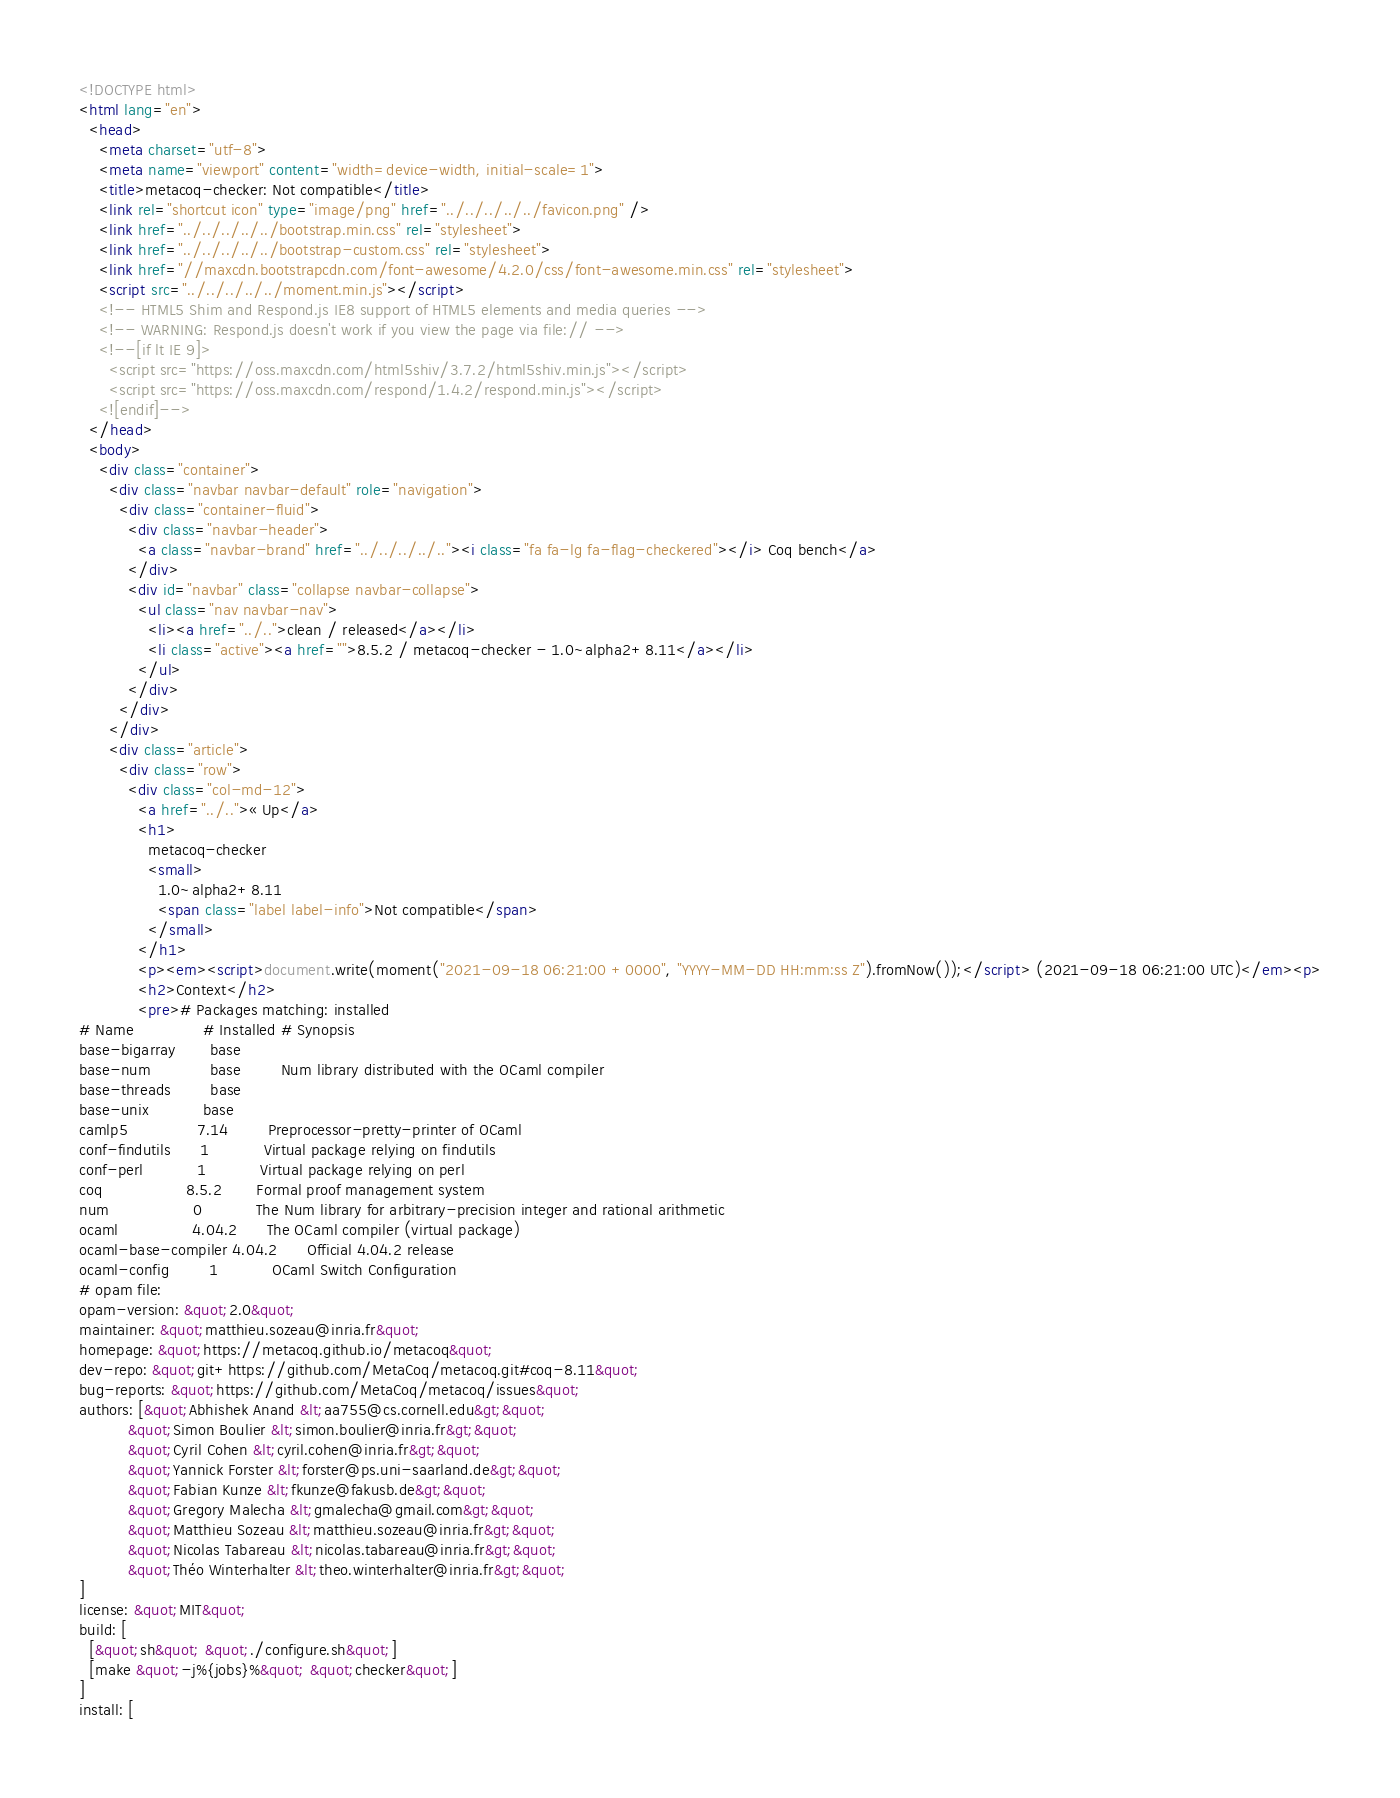<code> <loc_0><loc_0><loc_500><loc_500><_HTML_><!DOCTYPE html>
<html lang="en">
  <head>
    <meta charset="utf-8">
    <meta name="viewport" content="width=device-width, initial-scale=1">
    <title>metacoq-checker: Not compatible</title>
    <link rel="shortcut icon" type="image/png" href="../../../../../favicon.png" />
    <link href="../../../../../bootstrap.min.css" rel="stylesheet">
    <link href="../../../../../bootstrap-custom.css" rel="stylesheet">
    <link href="//maxcdn.bootstrapcdn.com/font-awesome/4.2.0/css/font-awesome.min.css" rel="stylesheet">
    <script src="../../../../../moment.min.js"></script>
    <!-- HTML5 Shim and Respond.js IE8 support of HTML5 elements and media queries -->
    <!-- WARNING: Respond.js doesn't work if you view the page via file:// -->
    <!--[if lt IE 9]>
      <script src="https://oss.maxcdn.com/html5shiv/3.7.2/html5shiv.min.js"></script>
      <script src="https://oss.maxcdn.com/respond/1.4.2/respond.min.js"></script>
    <![endif]-->
  </head>
  <body>
    <div class="container">
      <div class="navbar navbar-default" role="navigation">
        <div class="container-fluid">
          <div class="navbar-header">
            <a class="navbar-brand" href="../../../../.."><i class="fa fa-lg fa-flag-checkered"></i> Coq bench</a>
          </div>
          <div id="navbar" class="collapse navbar-collapse">
            <ul class="nav navbar-nav">
              <li><a href="../..">clean / released</a></li>
              <li class="active"><a href="">8.5.2 / metacoq-checker - 1.0~alpha2+8.11</a></li>
            </ul>
          </div>
        </div>
      </div>
      <div class="article">
        <div class="row">
          <div class="col-md-12">
            <a href="../..">« Up</a>
            <h1>
              metacoq-checker
              <small>
                1.0~alpha2+8.11
                <span class="label label-info">Not compatible</span>
              </small>
            </h1>
            <p><em><script>document.write(moment("2021-09-18 06:21:00 +0000", "YYYY-MM-DD HH:mm:ss Z").fromNow());</script> (2021-09-18 06:21:00 UTC)</em><p>
            <h2>Context</h2>
            <pre># Packages matching: installed
# Name              # Installed # Synopsis
base-bigarray       base
base-num            base        Num library distributed with the OCaml compiler
base-threads        base
base-unix           base
camlp5              7.14        Preprocessor-pretty-printer of OCaml
conf-findutils      1           Virtual package relying on findutils
conf-perl           1           Virtual package relying on perl
coq                 8.5.2       Formal proof management system
num                 0           The Num library for arbitrary-precision integer and rational arithmetic
ocaml               4.04.2      The OCaml compiler (virtual package)
ocaml-base-compiler 4.04.2      Official 4.04.2 release
ocaml-config        1           OCaml Switch Configuration
# opam file:
opam-version: &quot;2.0&quot;
maintainer: &quot;matthieu.sozeau@inria.fr&quot;
homepage: &quot;https://metacoq.github.io/metacoq&quot;
dev-repo: &quot;git+https://github.com/MetaCoq/metacoq.git#coq-8.11&quot;
bug-reports: &quot;https://github.com/MetaCoq/metacoq/issues&quot;
authors: [&quot;Abhishek Anand &lt;aa755@cs.cornell.edu&gt;&quot;
          &quot;Simon Boulier &lt;simon.boulier@inria.fr&gt;&quot;
          &quot;Cyril Cohen &lt;cyril.cohen@inria.fr&gt;&quot;
          &quot;Yannick Forster &lt;forster@ps.uni-saarland.de&gt;&quot;
          &quot;Fabian Kunze &lt;fkunze@fakusb.de&gt;&quot;
          &quot;Gregory Malecha &lt;gmalecha@gmail.com&gt;&quot;
          &quot;Matthieu Sozeau &lt;matthieu.sozeau@inria.fr&gt;&quot;
          &quot;Nicolas Tabareau &lt;nicolas.tabareau@inria.fr&gt;&quot;
          &quot;Théo Winterhalter &lt;theo.winterhalter@inria.fr&gt;&quot;
]
license: &quot;MIT&quot;
build: [
  [&quot;sh&quot; &quot;./configure.sh&quot;]
  [make &quot;-j%{jobs}%&quot; &quot;checker&quot;]
]
install: [</code> 